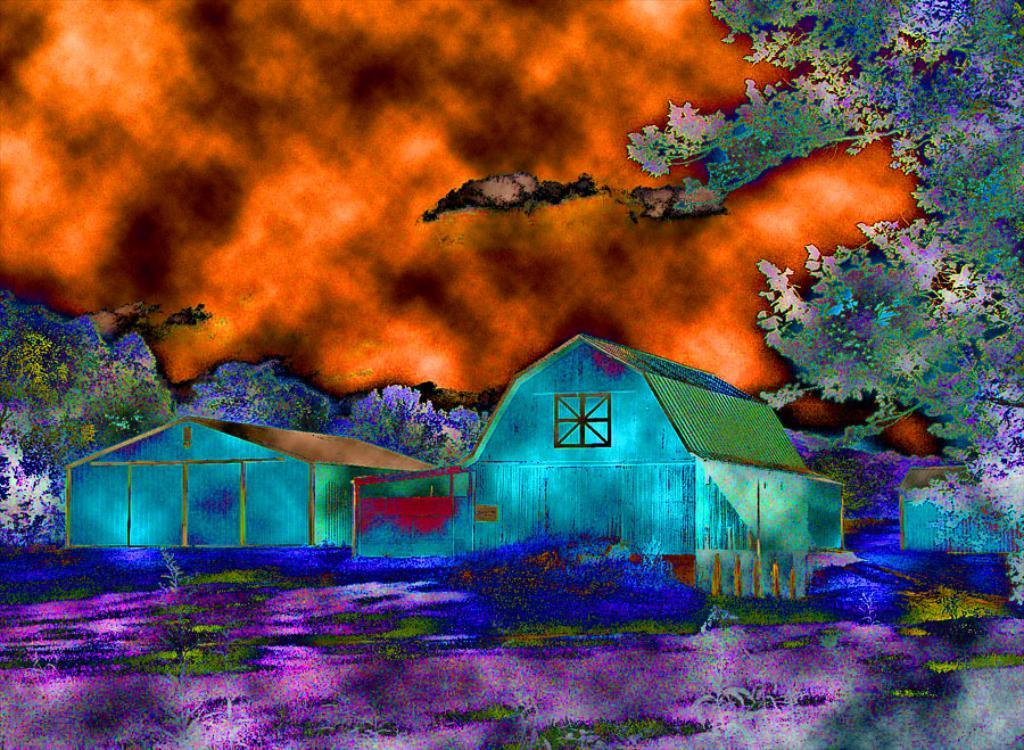What type of artwork is depicted in the image? The image is a painting. What structures can be seen in the painting? There are houses in the image. What type of vegetation is present in the painting? There are trees in the image. What is the ground covered with in the painting? There is grass on the ground in the image. What can be seen in the background of the painting? The sky is visible in the background of the image, and clouds are present in the sky. What day of the week is it in the painting? The painting does not depict a specific day of the week, as it is a static image. How many boys are playing in the grass in the painting? There are no boys present in the painting; it features houses, trees, grass, and the sky. 